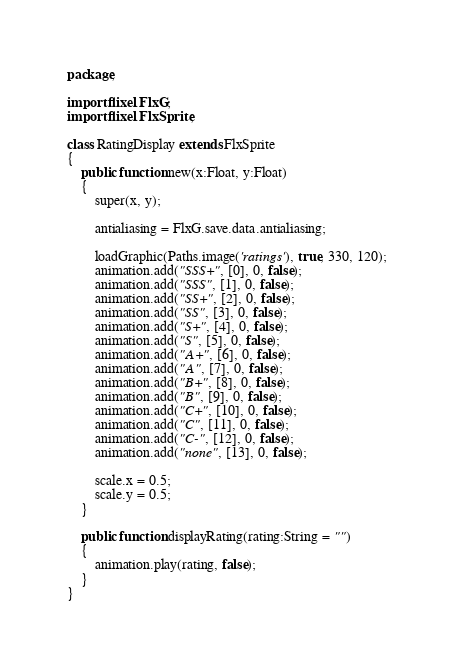<code> <loc_0><loc_0><loc_500><loc_500><_Haxe_>package;

import flixel.FlxG;
import flixel.FlxSprite;

class RatingDisplay extends FlxSprite
{
	public function new(x:Float, y:Float)
	{
		super(x, y);

		antialiasing = FlxG.save.data.antialiasing;

		loadGraphic(Paths.image('ratings'), true, 330, 120);
		animation.add("SSS+", [0], 0, false);
		animation.add("SSS", [1], 0, false);
		animation.add("SS+", [2], 0, false);
		animation.add("SS", [3], 0, false);
		animation.add("S+", [4], 0, false);
		animation.add("S", [5], 0, false);
		animation.add("A+", [6], 0, false);
		animation.add("A", [7], 0, false);
		animation.add("B+", [8], 0, false);
		animation.add("B", [9], 0, false);
		animation.add("C+", [10], 0, false);
		animation.add("C", [11], 0, false);
		animation.add("C-", [12], 0, false);
		animation.add("none", [13], 0, false);

		scale.x = 0.5;
		scale.y = 0.5;
	}

	public function displayRating(rating:String = "")
	{
		animation.play(rating, false);
	}
}
</code> 